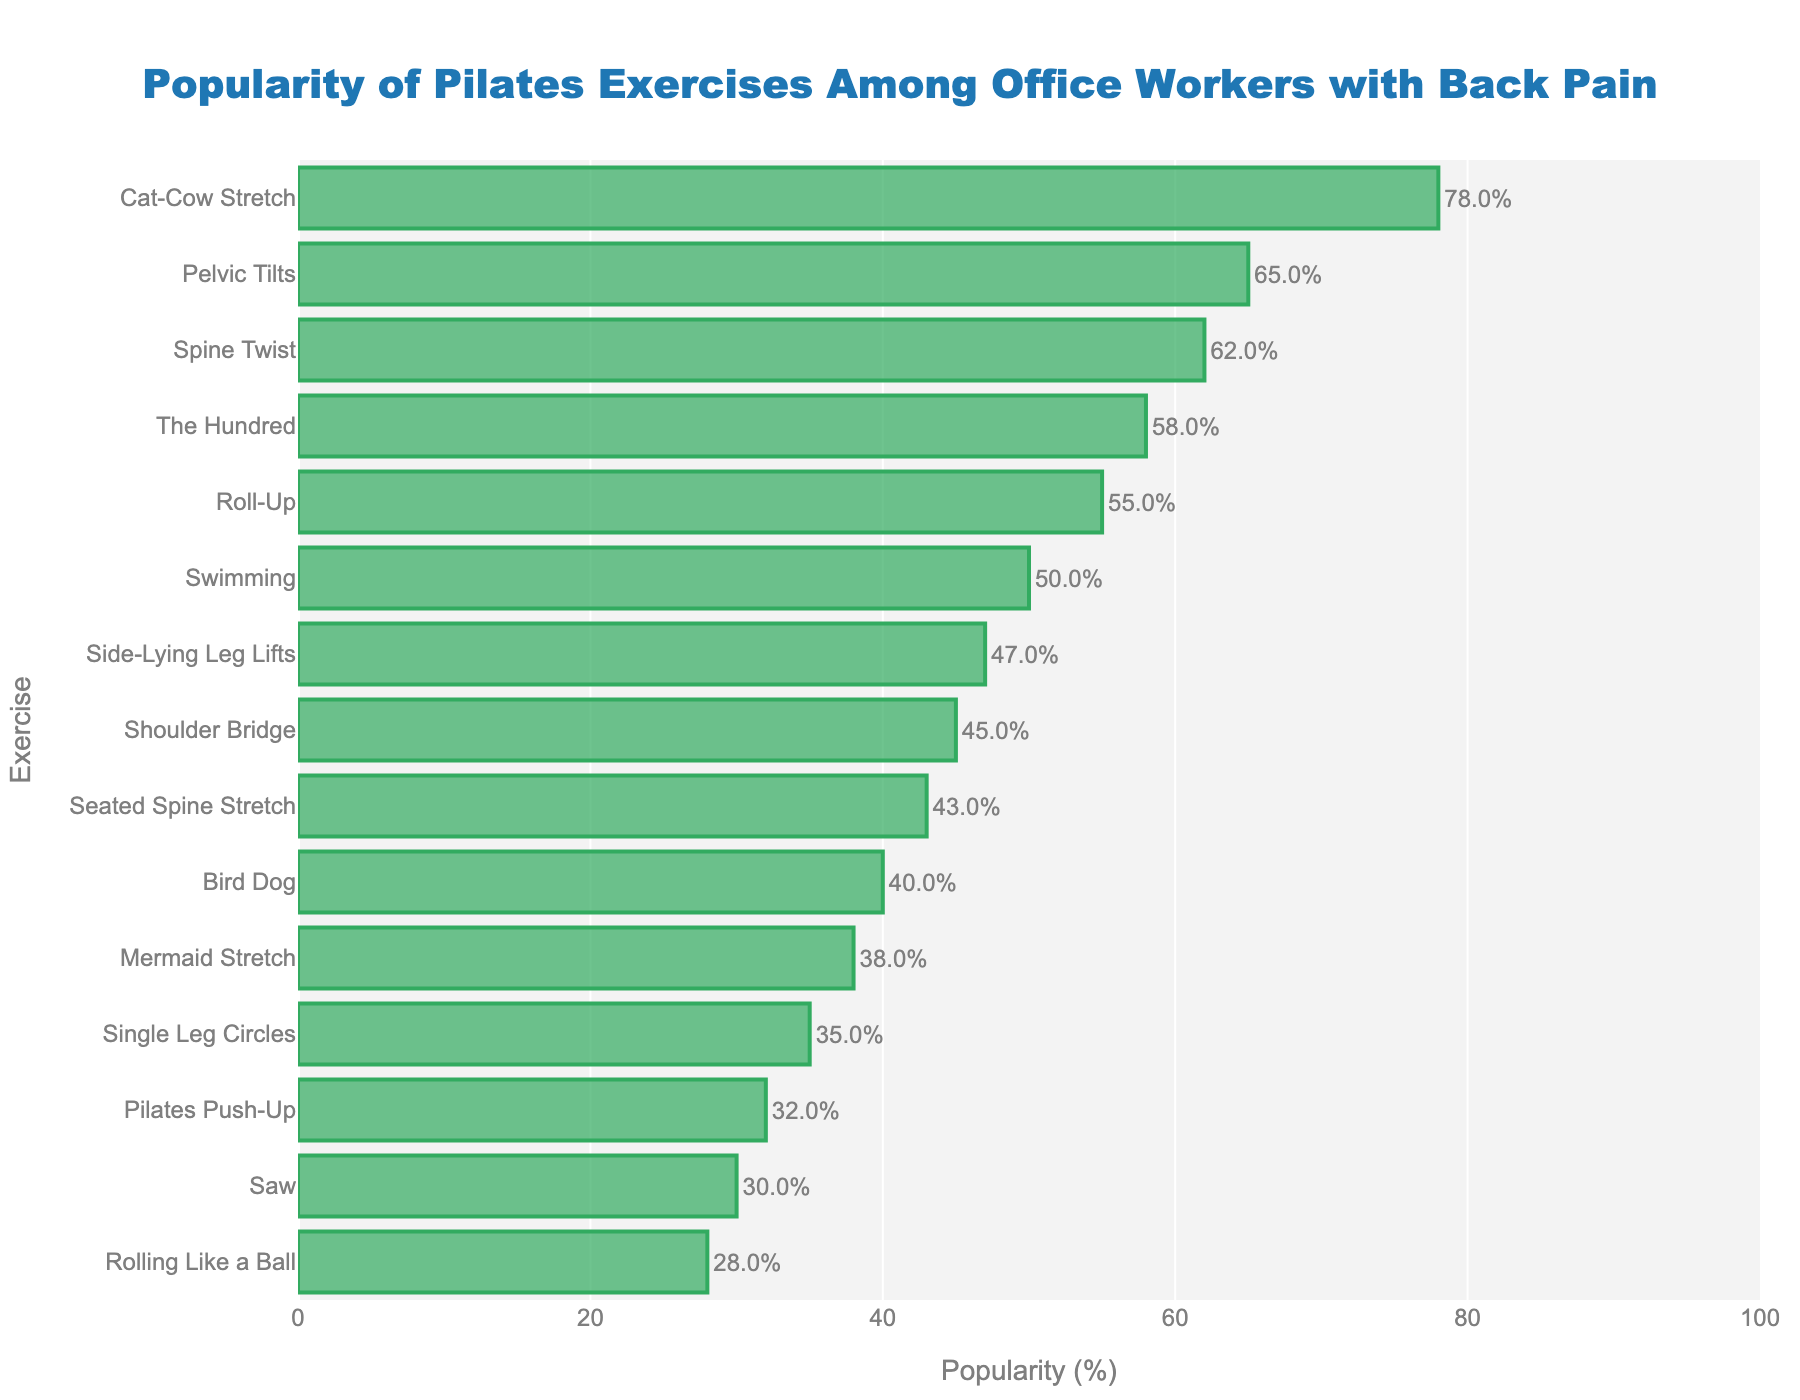Which Pilates exercise is the least popular among office workers with back pain? By looking at the figure, the exercise with the shortest bar represents the least popularity. The "Rolling Like a Ball" exercise has the shortest bar, corresponding to 28%.
Answer: Rolling Like a Ball Which Pilates exercise is the most popular among office workers with back pain? The exercise with the longest bar on the chart indicates the top popularity rate. The "Cat-Cow Stretch" has the longest bar, with 78%.
Answer: Cat-Cow Stretch How many exercises have a popularity percentage above 50%? By counting all the bars that extend past the 50% mark, we find the exercises: "Cat-Cow Stretch," "Pelvic Tilts," "Spine Twist," "The Hundred," and "Roll-Up," making a total of five exercises.
Answer: 5 What is the combined popularity percentage of "Side-Lying Leg Lifts" and "Bird Dog"? The popularity of "Side-Lying Leg Lifts" is 47%, and the popularity of "Bird Dog" is 40%. Adding these gives 47% + 40% = 87%.
Answer: 87% Which exercise is directly more popular than "Swimming"? Looking at the bar adjacent and above "Swimming" (which has 50% popularity), "Roll-Up" is directly more popular with 55%.
Answer: Roll-Up If you add the popularity percentages of the three least popular exercises, what is the total? The three least popular exercises are "Pilates Push-Up" (32%), "Saw" (30%), and "Rolling Like a Ball" (28%). Adding these percentages gives 32% + 30% + 28% = 90%.
Answer: 90% What is the average popularity of the top three most popular exercises? The top three most popular exercises are "Cat-Cow Stretch" (78%), "Pelvic Tilts" (65%), and "Spine Twist" (62%). The average is (78% + 65% + 62%) / 3 = 68.33%.
Answer: 68.33% Which exercise has a similar popularity rate to "Roll-Up"? Comparing popularity rates, "Swimming" has a popularity of 50%, which is close to "Roll-Up" with 55%.
Answer: Swimming Which exercise has a higher popularity: "Mermaid Stretch" or "Bird Dog"? "Bird Dog" has a popularity of 40%, while "Mermaid Stretch" has a popularity of 38%, making "Bird Dog" more popular.
Answer: Bird Dog Are there more exercises with popularity percentages above or below 50%? By counting the exercises, there are 5 exercises above 50%, and 10 exercises below 50%. There are more exercises below 50%.
Answer: Below 50% 